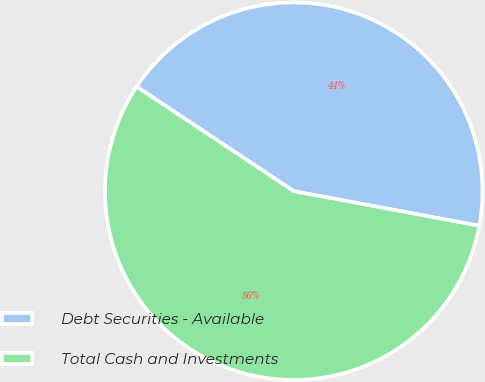<chart> <loc_0><loc_0><loc_500><loc_500><pie_chart><fcel>Debt Securities - Available<fcel>Total Cash and Investments<nl><fcel>43.59%<fcel>56.41%<nl></chart> 